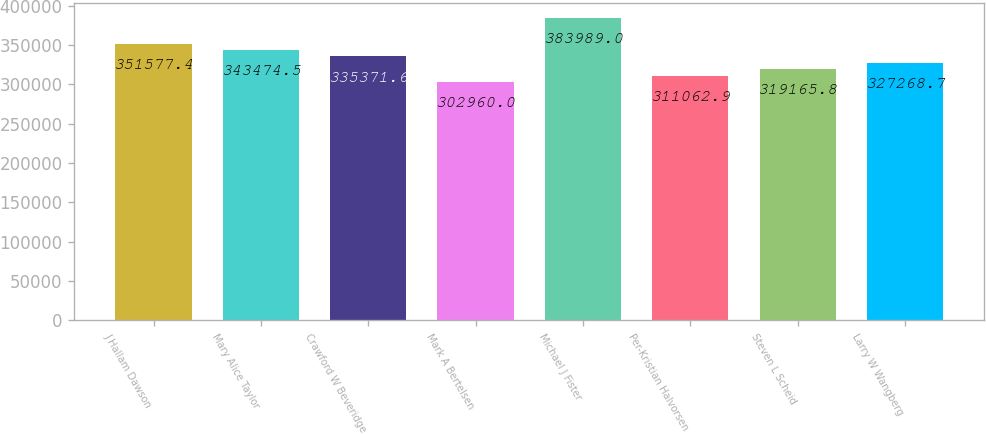<chart> <loc_0><loc_0><loc_500><loc_500><bar_chart><fcel>J Hallam Dawson<fcel>Mary Alice Taylor<fcel>Crawford W Beveridge<fcel>Mark A Bertelsen<fcel>Michael J Fister<fcel>Per-Kristian Halvorsen<fcel>Steven L Scheid<fcel>Larry W Wangberg<nl><fcel>351577<fcel>343474<fcel>335372<fcel>302960<fcel>383989<fcel>311063<fcel>319166<fcel>327269<nl></chart> 